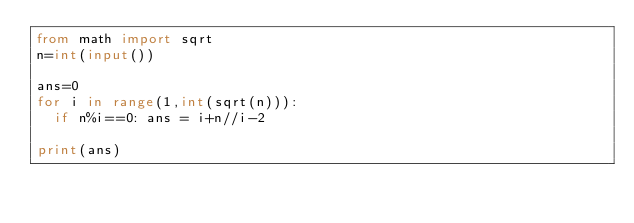Convert code to text. <code><loc_0><loc_0><loc_500><loc_500><_Python_>from math import sqrt
n=int(input())

ans=0
for i in range(1,int(sqrt(n))):
  if n%i==0: ans = i+n//i-2

print(ans)</code> 